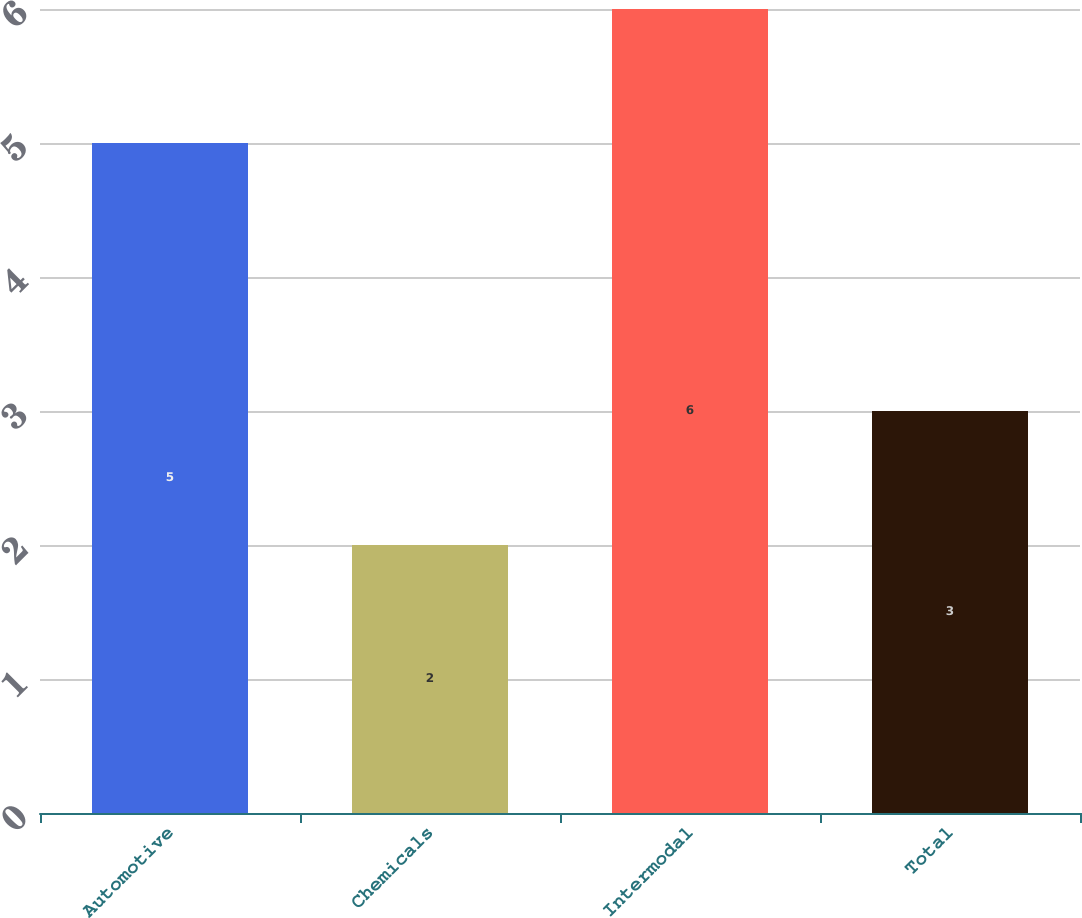Convert chart to OTSL. <chart><loc_0><loc_0><loc_500><loc_500><bar_chart><fcel>Automotive<fcel>Chemicals<fcel>Intermodal<fcel>Total<nl><fcel>5<fcel>2<fcel>6<fcel>3<nl></chart> 